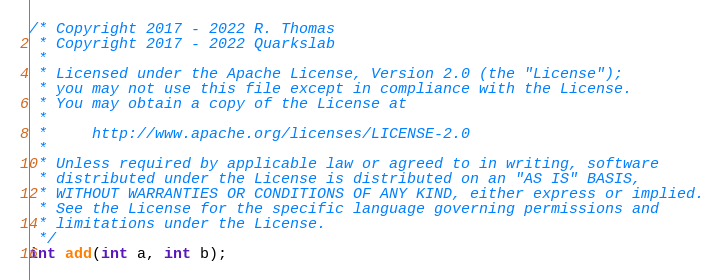Convert code to text. <code><loc_0><loc_0><loc_500><loc_500><_C_>/* Copyright 2017 - 2022 R. Thomas
 * Copyright 2017 - 2022 Quarkslab
 *
 * Licensed under the Apache License, Version 2.0 (the "License");
 * you may not use this file except in compliance with the License.
 * You may obtain a copy of the License at
 *
 *     http://www.apache.org/licenses/LICENSE-2.0
 *
 * Unless required by applicable law or agreed to in writing, software
 * distributed under the License is distributed on an "AS IS" BASIS,
 * WITHOUT WARRANTIES OR CONDITIONS OF ANY KIND, either express or implied.
 * See the License for the specific language governing permissions and
 * limitations under the License.
 */
int add(int a, int b);
</code> 